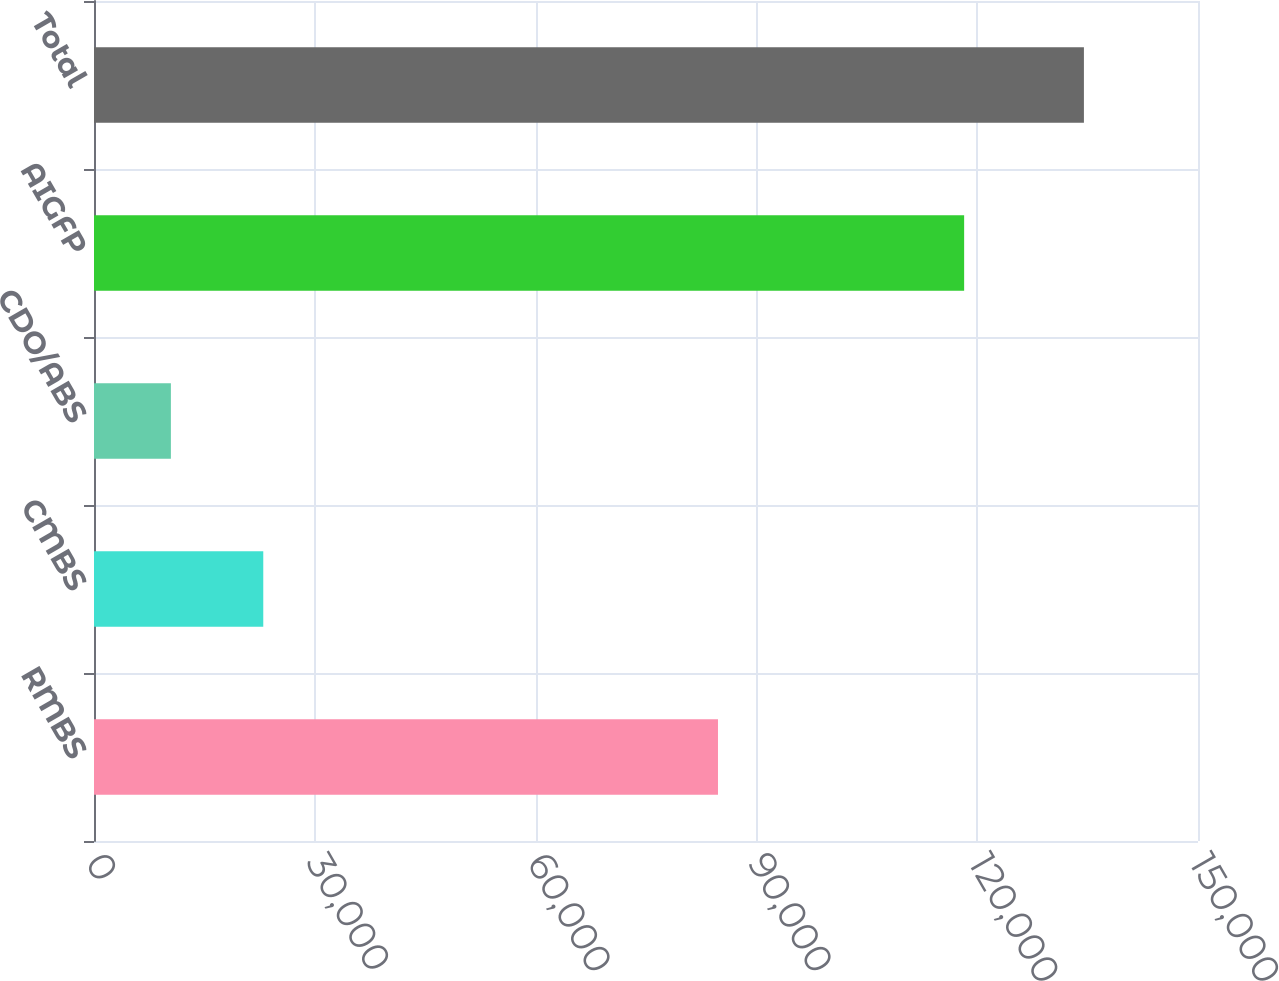Convert chart to OTSL. <chart><loc_0><loc_0><loc_500><loc_500><bar_chart><fcel>RMBS<fcel>CMBS<fcel>CDO/ABS<fcel>AIGFP<fcel>Total<nl><fcel>84780<fcel>22999<fcel>10447<fcel>118226<fcel>134500<nl></chart> 